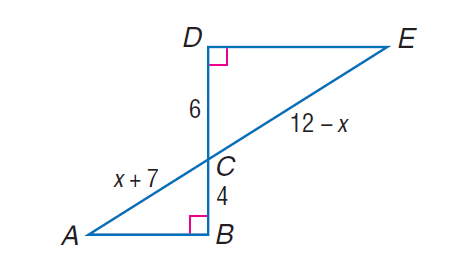Answer the mathemtical geometry problem and directly provide the correct option letter.
Question: Each pair of polygons is similar. Find C E.
Choices: A: 1.3 B: 5.4 C: 6 D: 11.4 D 